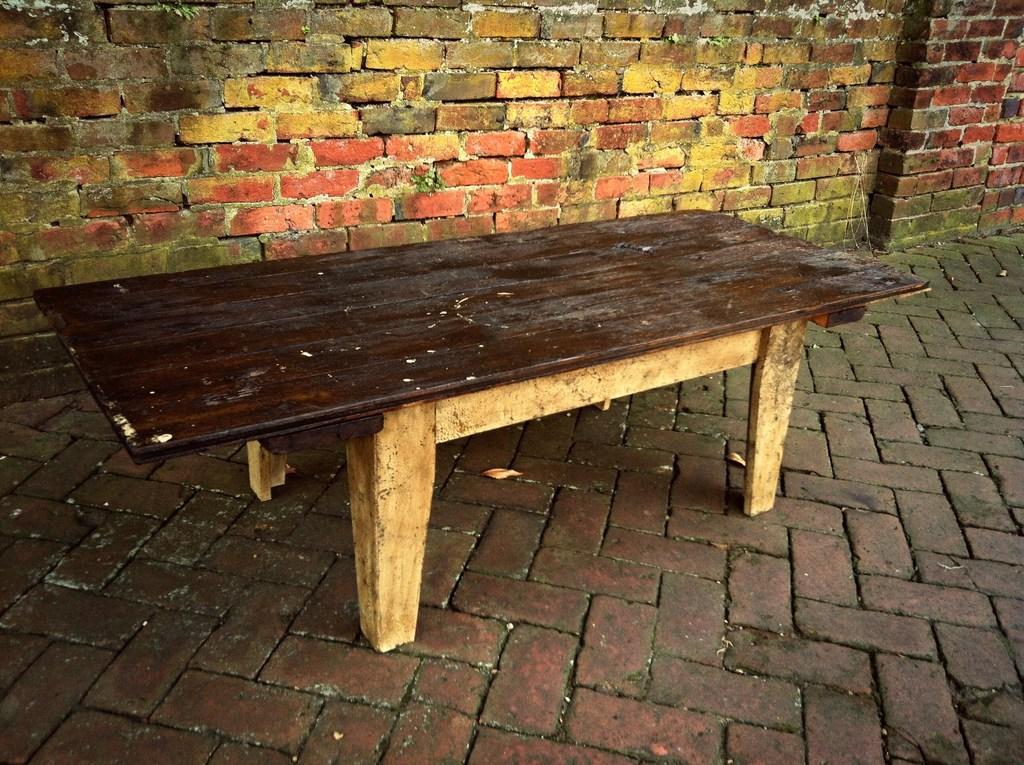Describe this image in one or two sentences. In this image we can see the wooden bench on the floor. In the background, we can see the brick wall. 